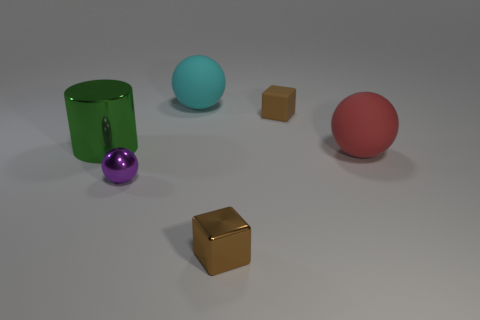Is there any other thing that has the same shape as the big red matte thing?
Ensure brevity in your answer.  Yes. There is another thing that is the same shape as the brown metallic thing; what color is it?
Ensure brevity in your answer.  Brown. How big is the green object?
Your answer should be compact. Large. Is the number of tiny purple things right of the big cyan matte ball less than the number of shiny spheres?
Your answer should be compact. Yes. Are the large red sphere and the brown thing behind the tiny purple shiny object made of the same material?
Offer a terse response. Yes. Are there any big green shiny cylinders that are right of the rubber thing that is on the left side of the block in front of the purple metallic sphere?
Make the answer very short. No. Is there any other thing that has the same size as the brown rubber thing?
Give a very brief answer. Yes. What color is the other large ball that is the same material as the large red ball?
Give a very brief answer. Cyan. There is a sphere that is on the left side of the red thing and behind the tiny purple metal thing; what size is it?
Provide a short and direct response. Large. Is the number of big green cylinders in front of the green object less than the number of big red matte balls right of the red matte object?
Provide a succinct answer. No. 